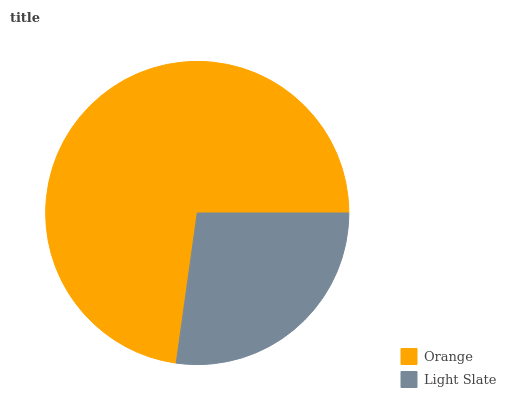Is Light Slate the minimum?
Answer yes or no. Yes. Is Orange the maximum?
Answer yes or no. Yes. Is Light Slate the maximum?
Answer yes or no. No. Is Orange greater than Light Slate?
Answer yes or no. Yes. Is Light Slate less than Orange?
Answer yes or no. Yes. Is Light Slate greater than Orange?
Answer yes or no. No. Is Orange less than Light Slate?
Answer yes or no. No. Is Orange the high median?
Answer yes or no. Yes. Is Light Slate the low median?
Answer yes or no. Yes. Is Light Slate the high median?
Answer yes or no. No. Is Orange the low median?
Answer yes or no. No. 